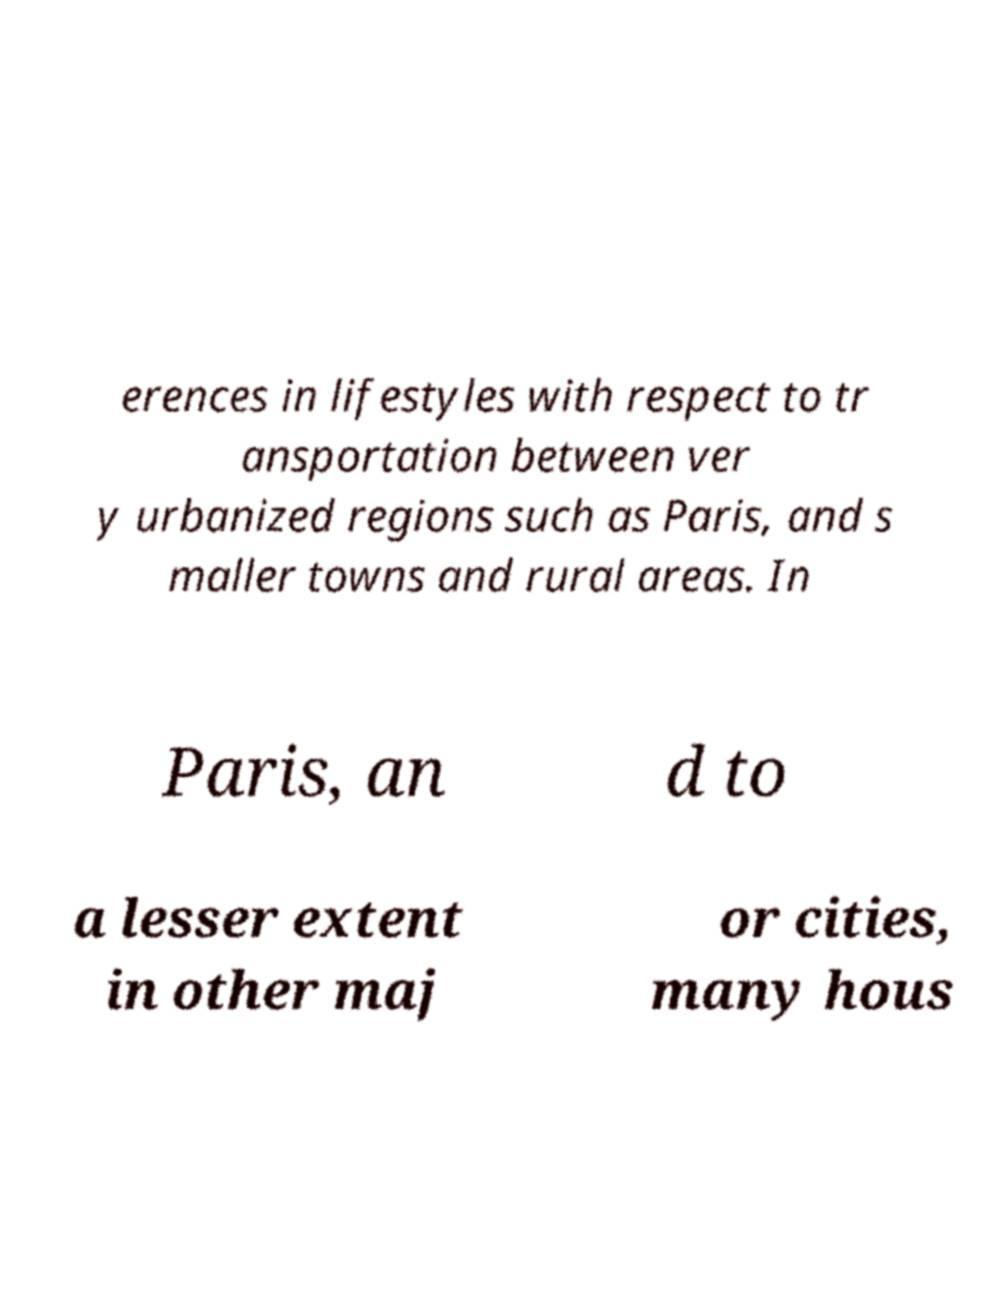Could you assist in decoding the text presented in this image and type it out clearly? erences in lifestyles with respect to tr ansportation between ver y urbanized regions such as Paris, and s maller towns and rural areas. In Paris, an d to a lesser extent in other maj or cities, many hous 